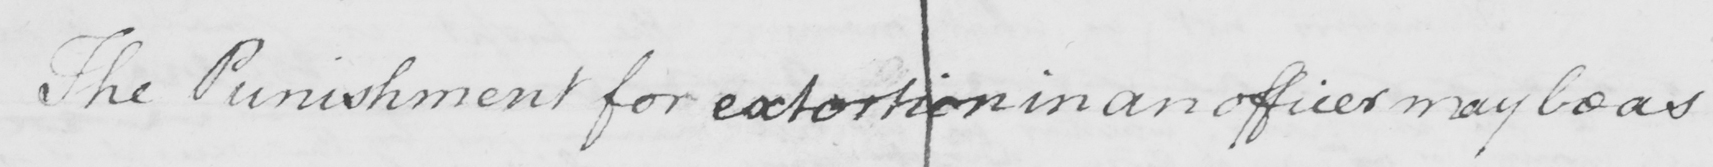Can you read and transcribe this handwriting? The Punishment for extortion in an officer may be as 